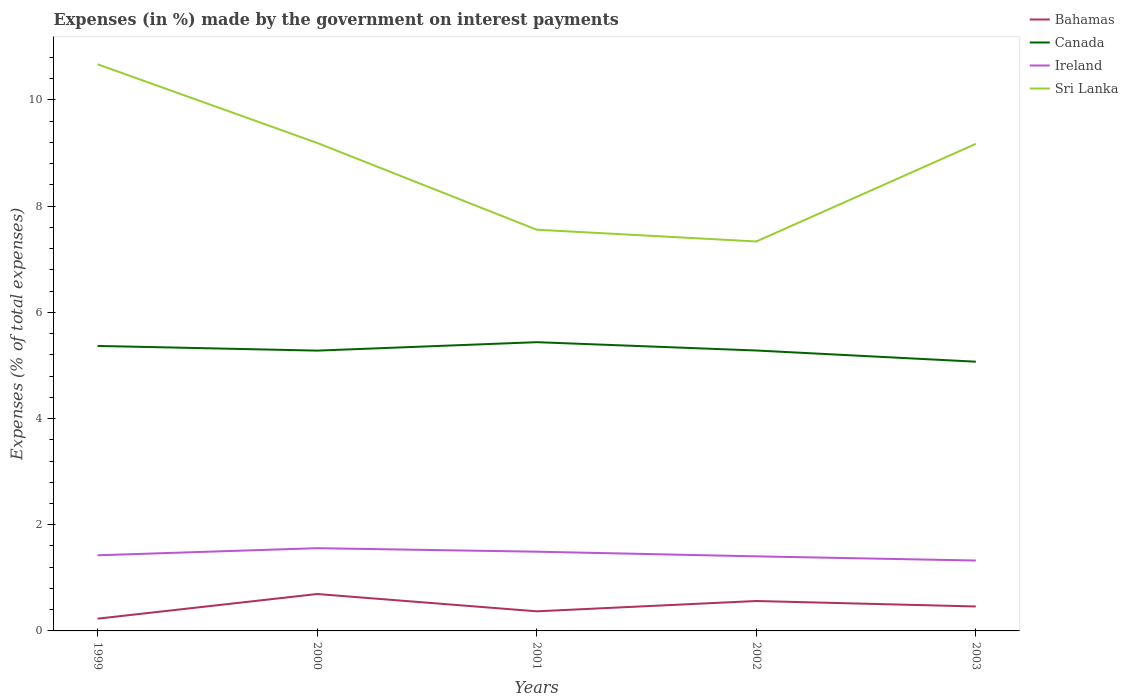How many different coloured lines are there?
Provide a succinct answer. 4. Does the line corresponding to Ireland intersect with the line corresponding to Sri Lanka?
Your answer should be very brief. No. Is the number of lines equal to the number of legend labels?
Your response must be concise. Yes. Across all years, what is the maximum percentage of expenses made by the government on interest payments in Sri Lanka?
Your response must be concise. 7.33. In which year was the percentage of expenses made by the government on interest payments in Ireland maximum?
Give a very brief answer. 2003. What is the total percentage of expenses made by the government on interest payments in Canada in the graph?
Your response must be concise. -0.16. What is the difference between the highest and the second highest percentage of expenses made by the government on interest payments in Ireland?
Offer a terse response. 0.23. What is the difference between the highest and the lowest percentage of expenses made by the government on interest payments in Bahamas?
Ensure brevity in your answer.  2. Is the percentage of expenses made by the government on interest payments in Ireland strictly greater than the percentage of expenses made by the government on interest payments in Sri Lanka over the years?
Give a very brief answer. Yes. What is the difference between two consecutive major ticks on the Y-axis?
Ensure brevity in your answer.  2. Does the graph contain any zero values?
Provide a short and direct response. No. How many legend labels are there?
Provide a succinct answer. 4. How are the legend labels stacked?
Offer a terse response. Vertical. What is the title of the graph?
Your answer should be compact. Expenses (in %) made by the government on interest payments. Does "Slovak Republic" appear as one of the legend labels in the graph?
Your answer should be compact. No. What is the label or title of the Y-axis?
Offer a very short reply. Expenses (% of total expenses). What is the Expenses (% of total expenses) in Bahamas in 1999?
Ensure brevity in your answer.  0.23. What is the Expenses (% of total expenses) of Canada in 1999?
Give a very brief answer. 5.37. What is the Expenses (% of total expenses) of Ireland in 1999?
Provide a succinct answer. 1.42. What is the Expenses (% of total expenses) of Sri Lanka in 1999?
Give a very brief answer. 10.67. What is the Expenses (% of total expenses) of Bahamas in 2000?
Your answer should be very brief. 0.7. What is the Expenses (% of total expenses) of Canada in 2000?
Your answer should be very brief. 5.28. What is the Expenses (% of total expenses) of Ireland in 2000?
Provide a short and direct response. 1.56. What is the Expenses (% of total expenses) of Sri Lanka in 2000?
Your answer should be compact. 9.19. What is the Expenses (% of total expenses) of Bahamas in 2001?
Ensure brevity in your answer.  0.37. What is the Expenses (% of total expenses) of Canada in 2001?
Your answer should be very brief. 5.44. What is the Expenses (% of total expenses) in Ireland in 2001?
Keep it short and to the point. 1.49. What is the Expenses (% of total expenses) in Sri Lanka in 2001?
Your answer should be very brief. 7.56. What is the Expenses (% of total expenses) of Bahamas in 2002?
Provide a short and direct response. 0.56. What is the Expenses (% of total expenses) in Canada in 2002?
Ensure brevity in your answer.  5.28. What is the Expenses (% of total expenses) of Ireland in 2002?
Provide a succinct answer. 1.4. What is the Expenses (% of total expenses) of Sri Lanka in 2002?
Provide a short and direct response. 7.33. What is the Expenses (% of total expenses) of Bahamas in 2003?
Provide a short and direct response. 0.46. What is the Expenses (% of total expenses) in Canada in 2003?
Keep it short and to the point. 5.07. What is the Expenses (% of total expenses) of Ireland in 2003?
Keep it short and to the point. 1.33. What is the Expenses (% of total expenses) of Sri Lanka in 2003?
Provide a short and direct response. 9.17. Across all years, what is the maximum Expenses (% of total expenses) in Bahamas?
Give a very brief answer. 0.7. Across all years, what is the maximum Expenses (% of total expenses) of Canada?
Provide a short and direct response. 5.44. Across all years, what is the maximum Expenses (% of total expenses) of Ireland?
Your answer should be compact. 1.56. Across all years, what is the maximum Expenses (% of total expenses) in Sri Lanka?
Make the answer very short. 10.67. Across all years, what is the minimum Expenses (% of total expenses) of Bahamas?
Ensure brevity in your answer.  0.23. Across all years, what is the minimum Expenses (% of total expenses) of Canada?
Offer a terse response. 5.07. Across all years, what is the minimum Expenses (% of total expenses) in Ireland?
Provide a succinct answer. 1.33. Across all years, what is the minimum Expenses (% of total expenses) of Sri Lanka?
Provide a succinct answer. 7.33. What is the total Expenses (% of total expenses) of Bahamas in the graph?
Provide a succinct answer. 2.32. What is the total Expenses (% of total expenses) in Canada in the graph?
Your answer should be compact. 26.44. What is the total Expenses (% of total expenses) of Ireland in the graph?
Give a very brief answer. 7.21. What is the total Expenses (% of total expenses) in Sri Lanka in the graph?
Give a very brief answer. 43.92. What is the difference between the Expenses (% of total expenses) in Bahamas in 1999 and that in 2000?
Your answer should be very brief. -0.46. What is the difference between the Expenses (% of total expenses) of Canada in 1999 and that in 2000?
Ensure brevity in your answer.  0.09. What is the difference between the Expenses (% of total expenses) in Ireland in 1999 and that in 2000?
Provide a short and direct response. -0.13. What is the difference between the Expenses (% of total expenses) of Sri Lanka in 1999 and that in 2000?
Offer a terse response. 1.48. What is the difference between the Expenses (% of total expenses) of Bahamas in 1999 and that in 2001?
Give a very brief answer. -0.14. What is the difference between the Expenses (% of total expenses) of Canada in 1999 and that in 2001?
Keep it short and to the point. -0.07. What is the difference between the Expenses (% of total expenses) of Ireland in 1999 and that in 2001?
Ensure brevity in your answer.  -0.07. What is the difference between the Expenses (% of total expenses) in Sri Lanka in 1999 and that in 2001?
Make the answer very short. 3.12. What is the difference between the Expenses (% of total expenses) of Bahamas in 1999 and that in 2002?
Your response must be concise. -0.33. What is the difference between the Expenses (% of total expenses) of Canada in 1999 and that in 2002?
Keep it short and to the point. 0.09. What is the difference between the Expenses (% of total expenses) in Sri Lanka in 1999 and that in 2002?
Your answer should be very brief. 3.34. What is the difference between the Expenses (% of total expenses) of Bahamas in 1999 and that in 2003?
Make the answer very short. -0.23. What is the difference between the Expenses (% of total expenses) of Canada in 1999 and that in 2003?
Provide a short and direct response. 0.3. What is the difference between the Expenses (% of total expenses) in Ireland in 1999 and that in 2003?
Provide a short and direct response. 0.1. What is the difference between the Expenses (% of total expenses) in Sri Lanka in 1999 and that in 2003?
Provide a short and direct response. 1.5. What is the difference between the Expenses (% of total expenses) in Bahamas in 2000 and that in 2001?
Your answer should be compact. 0.33. What is the difference between the Expenses (% of total expenses) of Canada in 2000 and that in 2001?
Provide a succinct answer. -0.16. What is the difference between the Expenses (% of total expenses) in Ireland in 2000 and that in 2001?
Offer a terse response. 0.07. What is the difference between the Expenses (% of total expenses) in Sri Lanka in 2000 and that in 2001?
Your answer should be very brief. 1.63. What is the difference between the Expenses (% of total expenses) in Bahamas in 2000 and that in 2002?
Ensure brevity in your answer.  0.13. What is the difference between the Expenses (% of total expenses) of Canada in 2000 and that in 2002?
Ensure brevity in your answer.  -0. What is the difference between the Expenses (% of total expenses) of Ireland in 2000 and that in 2002?
Give a very brief answer. 0.15. What is the difference between the Expenses (% of total expenses) in Sri Lanka in 2000 and that in 2002?
Your response must be concise. 1.86. What is the difference between the Expenses (% of total expenses) of Bahamas in 2000 and that in 2003?
Provide a succinct answer. 0.23. What is the difference between the Expenses (% of total expenses) in Canada in 2000 and that in 2003?
Make the answer very short. 0.21. What is the difference between the Expenses (% of total expenses) of Ireland in 2000 and that in 2003?
Offer a very short reply. 0.23. What is the difference between the Expenses (% of total expenses) in Sri Lanka in 2000 and that in 2003?
Keep it short and to the point. 0.02. What is the difference between the Expenses (% of total expenses) in Bahamas in 2001 and that in 2002?
Give a very brief answer. -0.19. What is the difference between the Expenses (% of total expenses) in Canada in 2001 and that in 2002?
Ensure brevity in your answer.  0.16. What is the difference between the Expenses (% of total expenses) in Ireland in 2001 and that in 2002?
Provide a short and direct response. 0.09. What is the difference between the Expenses (% of total expenses) in Sri Lanka in 2001 and that in 2002?
Provide a short and direct response. 0.22. What is the difference between the Expenses (% of total expenses) of Bahamas in 2001 and that in 2003?
Your answer should be compact. -0.09. What is the difference between the Expenses (% of total expenses) of Canada in 2001 and that in 2003?
Ensure brevity in your answer.  0.37. What is the difference between the Expenses (% of total expenses) in Ireland in 2001 and that in 2003?
Offer a terse response. 0.17. What is the difference between the Expenses (% of total expenses) in Sri Lanka in 2001 and that in 2003?
Provide a succinct answer. -1.62. What is the difference between the Expenses (% of total expenses) in Bahamas in 2002 and that in 2003?
Your answer should be compact. 0.1. What is the difference between the Expenses (% of total expenses) of Canada in 2002 and that in 2003?
Offer a very short reply. 0.21. What is the difference between the Expenses (% of total expenses) in Ireland in 2002 and that in 2003?
Your answer should be compact. 0.08. What is the difference between the Expenses (% of total expenses) in Sri Lanka in 2002 and that in 2003?
Your answer should be compact. -1.84. What is the difference between the Expenses (% of total expenses) of Bahamas in 1999 and the Expenses (% of total expenses) of Canada in 2000?
Your answer should be compact. -5.05. What is the difference between the Expenses (% of total expenses) of Bahamas in 1999 and the Expenses (% of total expenses) of Ireland in 2000?
Your response must be concise. -1.33. What is the difference between the Expenses (% of total expenses) in Bahamas in 1999 and the Expenses (% of total expenses) in Sri Lanka in 2000?
Offer a very short reply. -8.96. What is the difference between the Expenses (% of total expenses) of Canada in 1999 and the Expenses (% of total expenses) of Ireland in 2000?
Make the answer very short. 3.81. What is the difference between the Expenses (% of total expenses) of Canada in 1999 and the Expenses (% of total expenses) of Sri Lanka in 2000?
Provide a short and direct response. -3.82. What is the difference between the Expenses (% of total expenses) in Ireland in 1999 and the Expenses (% of total expenses) in Sri Lanka in 2000?
Your answer should be very brief. -7.77. What is the difference between the Expenses (% of total expenses) of Bahamas in 1999 and the Expenses (% of total expenses) of Canada in 2001?
Your answer should be compact. -5.21. What is the difference between the Expenses (% of total expenses) in Bahamas in 1999 and the Expenses (% of total expenses) in Ireland in 2001?
Your response must be concise. -1.26. What is the difference between the Expenses (% of total expenses) in Bahamas in 1999 and the Expenses (% of total expenses) in Sri Lanka in 2001?
Provide a succinct answer. -7.33. What is the difference between the Expenses (% of total expenses) in Canada in 1999 and the Expenses (% of total expenses) in Ireland in 2001?
Ensure brevity in your answer.  3.88. What is the difference between the Expenses (% of total expenses) of Canada in 1999 and the Expenses (% of total expenses) of Sri Lanka in 2001?
Offer a terse response. -2.19. What is the difference between the Expenses (% of total expenses) of Ireland in 1999 and the Expenses (% of total expenses) of Sri Lanka in 2001?
Make the answer very short. -6.13. What is the difference between the Expenses (% of total expenses) in Bahamas in 1999 and the Expenses (% of total expenses) in Canada in 2002?
Provide a succinct answer. -5.05. What is the difference between the Expenses (% of total expenses) of Bahamas in 1999 and the Expenses (% of total expenses) of Ireland in 2002?
Offer a terse response. -1.17. What is the difference between the Expenses (% of total expenses) of Bahamas in 1999 and the Expenses (% of total expenses) of Sri Lanka in 2002?
Offer a terse response. -7.1. What is the difference between the Expenses (% of total expenses) in Canada in 1999 and the Expenses (% of total expenses) in Ireland in 2002?
Keep it short and to the point. 3.96. What is the difference between the Expenses (% of total expenses) in Canada in 1999 and the Expenses (% of total expenses) in Sri Lanka in 2002?
Your answer should be very brief. -1.97. What is the difference between the Expenses (% of total expenses) of Ireland in 1999 and the Expenses (% of total expenses) of Sri Lanka in 2002?
Offer a terse response. -5.91. What is the difference between the Expenses (% of total expenses) of Bahamas in 1999 and the Expenses (% of total expenses) of Canada in 2003?
Offer a terse response. -4.84. What is the difference between the Expenses (% of total expenses) in Bahamas in 1999 and the Expenses (% of total expenses) in Ireland in 2003?
Ensure brevity in your answer.  -1.09. What is the difference between the Expenses (% of total expenses) in Bahamas in 1999 and the Expenses (% of total expenses) in Sri Lanka in 2003?
Give a very brief answer. -8.94. What is the difference between the Expenses (% of total expenses) in Canada in 1999 and the Expenses (% of total expenses) in Ireland in 2003?
Provide a short and direct response. 4.04. What is the difference between the Expenses (% of total expenses) of Canada in 1999 and the Expenses (% of total expenses) of Sri Lanka in 2003?
Your answer should be very brief. -3.81. What is the difference between the Expenses (% of total expenses) in Ireland in 1999 and the Expenses (% of total expenses) in Sri Lanka in 2003?
Make the answer very short. -7.75. What is the difference between the Expenses (% of total expenses) in Bahamas in 2000 and the Expenses (% of total expenses) in Canada in 2001?
Your answer should be very brief. -4.74. What is the difference between the Expenses (% of total expenses) of Bahamas in 2000 and the Expenses (% of total expenses) of Ireland in 2001?
Your answer should be very brief. -0.8. What is the difference between the Expenses (% of total expenses) of Bahamas in 2000 and the Expenses (% of total expenses) of Sri Lanka in 2001?
Ensure brevity in your answer.  -6.86. What is the difference between the Expenses (% of total expenses) of Canada in 2000 and the Expenses (% of total expenses) of Ireland in 2001?
Make the answer very short. 3.79. What is the difference between the Expenses (% of total expenses) in Canada in 2000 and the Expenses (% of total expenses) in Sri Lanka in 2001?
Give a very brief answer. -2.28. What is the difference between the Expenses (% of total expenses) of Ireland in 2000 and the Expenses (% of total expenses) of Sri Lanka in 2001?
Your response must be concise. -6. What is the difference between the Expenses (% of total expenses) of Bahamas in 2000 and the Expenses (% of total expenses) of Canada in 2002?
Keep it short and to the point. -4.59. What is the difference between the Expenses (% of total expenses) of Bahamas in 2000 and the Expenses (% of total expenses) of Ireland in 2002?
Your answer should be very brief. -0.71. What is the difference between the Expenses (% of total expenses) in Bahamas in 2000 and the Expenses (% of total expenses) in Sri Lanka in 2002?
Provide a succinct answer. -6.64. What is the difference between the Expenses (% of total expenses) in Canada in 2000 and the Expenses (% of total expenses) in Ireland in 2002?
Give a very brief answer. 3.87. What is the difference between the Expenses (% of total expenses) in Canada in 2000 and the Expenses (% of total expenses) in Sri Lanka in 2002?
Offer a very short reply. -2.06. What is the difference between the Expenses (% of total expenses) in Ireland in 2000 and the Expenses (% of total expenses) in Sri Lanka in 2002?
Ensure brevity in your answer.  -5.78. What is the difference between the Expenses (% of total expenses) of Bahamas in 2000 and the Expenses (% of total expenses) of Canada in 2003?
Your response must be concise. -4.38. What is the difference between the Expenses (% of total expenses) of Bahamas in 2000 and the Expenses (% of total expenses) of Ireland in 2003?
Make the answer very short. -0.63. What is the difference between the Expenses (% of total expenses) of Bahamas in 2000 and the Expenses (% of total expenses) of Sri Lanka in 2003?
Give a very brief answer. -8.48. What is the difference between the Expenses (% of total expenses) of Canada in 2000 and the Expenses (% of total expenses) of Ireland in 2003?
Provide a short and direct response. 3.95. What is the difference between the Expenses (% of total expenses) of Canada in 2000 and the Expenses (% of total expenses) of Sri Lanka in 2003?
Ensure brevity in your answer.  -3.89. What is the difference between the Expenses (% of total expenses) in Ireland in 2000 and the Expenses (% of total expenses) in Sri Lanka in 2003?
Offer a terse response. -7.61. What is the difference between the Expenses (% of total expenses) in Bahamas in 2001 and the Expenses (% of total expenses) in Canada in 2002?
Provide a short and direct response. -4.91. What is the difference between the Expenses (% of total expenses) in Bahamas in 2001 and the Expenses (% of total expenses) in Ireland in 2002?
Make the answer very short. -1.04. What is the difference between the Expenses (% of total expenses) in Bahamas in 2001 and the Expenses (% of total expenses) in Sri Lanka in 2002?
Your response must be concise. -6.97. What is the difference between the Expenses (% of total expenses) of Canada in 2001 and the Expenses (% of total expenses) of Ireland in 2002?
Your answer should be compact. 4.03. What is the difference between the Expenses (% of total expenses) in Canada in 2001 and the Expenses (% of total expenses) in Sri Lanka in 2002?
Your response must be concise. -1.9. What is the difference between the Expenses (% of total expenses) of Ireland in 2001 and the Expenses (% of total expenses) of Sri Lanka in 2002?
Offer a very short reply. -5.84. What is the difference between the Expenses (% of total expenses) in Bahamas in 2001 and the Expenses (% of total expenses) in Canada in 2003?
Provide a short and direct response. -4.7. What is the difference between the Expenses (% of total expenses) in Bahamas in 2001 and the Expenses (% of total expenses) in Ireland in 2003?
Offer a very short reply. -0.96. What is the difference between the Expenses (% of total expenses) in Bahamas in 2001 and the Expenses (% of total expenses) in Sri Lanka in 2003?
Make the answer very short. -8.8. What is the difference between the Expenses (% of total expenses) of Canada in 2001 and the Expenses (% of total expenses) of Ireland in 2003?
Your answer should be very brief. 4.11. What is the difference between the Expenses (% of total expenses) of Canada in 2001 and the Expenses (% of total expenses) of Sri Lanka in 2003?
Keep it short and to the point. -3.73. What is the difference between the Expenses (% of total expenses) of Ireland in 2001 and the Expenses (% of total expenses) of Sri Lanka in 2003?
Give a very brief answer. -7.68. What is the difference between the Expenses (% of total expenses) of Bahamas in 2002 and the Expenses (% of total expenses) of Canada in 2003?
Give a very brief answer. -4.51. What is the difference between the Expenses (% of total expenses) in Bahamas in 2002 and the Expenses (% of total expenses) in Ireland in 2003?
Your response must be concise. -0.76. What is the difference between the Expenses (% of total expenses) of Bahamas in 2002 and the Expenses (% of total expenses) of Sri Lanka in 2003?
Your response must be concise. -8.61. What is the difference between the Expenses (% of total expenses) of Canada in 2002 and the Expenses (% of total expenses) of Ireland in 2003?
Provide a short and direct response. 3.96. What is the difference between the Expenses (% of total expenses) in Canada in 2002 and the Expenses (% of total expenses) in Sri Lanka in 2003?
Give a very brief answer. -3.89. What is the difference between the Expenses (% of total expenses) in Ireland in 2002 and the Expenses (% of total expenses) in Sri Lanka in 2003?
Ensure brevity in your answer.  -7.77. What is the average Expenses (% of total expenses) in Bahamas per year?
Give a very brief answer. 0.46. What is the average Expenses (% of total expenses) in Canada per year?
Make the answer very short. 5.29. What is the average Expenses (% of total expenses) in Ireland per year?
Your response must be concise. 1.44. What is the average Expenses (% of total expenses) in Sri Lanka per year?
Provide a succinct answer. 8.78. In the year 1999, what is the difference between the Expenses (% of total expenses) in Bahamas and Expenses (% of total expenses) in Canada?
Offer a terse response. -5.14. In the year 1999, what is the difference between the Expenses (% of total expenses) in Bahamas and Expenses (% of total expenses) in Ireland?
Keep it short and to the point. -1.19. In the year 1999, what is the difference between the Expenses (% of total expenses) in Bahamas and Expenses (% of total expenses) in Sri Lanka?
Offer a terse response. -10.44. In the year 1999, what is the difference between the Expenses (% of total expenses) of Canada and Expenses (% of total expenses) of Ireland?
Your answer should be very brief. 3.94. In the year 1999, what is the difference between the Expenses (% of total expenses) of Canada and Expenses (% of total expenses) of Sri Lanka?
Make the answer very short. -5.3. In the year 1999, what is the difference between the Expenses (% of total expenses) of Ireland and Expenses (% of total expenses) of Sri Lanka?
Keep it short and to the point. -9.25. In the year 2000, what is the difference between the Expenses (% of total expenses) in Bahamas and Expenses (% of total expenses) in Canada?
Ensure brevity in your answer.  -4.58. In the year 2000, what is the difference between the Expenses (% of total expenses) in Bahamas and Expenses (% of total expenses) in Ireland?
Provide a short and direct response. -0.86. In the year 2000, what is the difference between the Expenses (% of total expenses) of Bahamas and Expenses (% of total expenses) of Sri Lanka?
Offer a very short reply. -8.5. In the year 2000, what is the difference between the Expenses (% of total expenses) of Canada and Expenses (% of total expenses) of Ireland?
Your response must be concise. 3.72. In the year 2000, what is the difference between the Expenses (% of total expenses) of Canada and Expenses (% of total expenses) of Sri Lanka?
Your answer should be compact. -3.91. In the year 2000, what is the difference between the Expenses (% of total expenses) of Ireland and Expenses (% of total expenses) of Sri Lanka?
Keep it short and to the point. -7.63. In the year 2001, what is the difference between the Expenses (% of total expenses) of Bahamas and Expenses (% of total expenses) of Canada?
Provide a succinct answer. -5.07. In the year 2001, what is the difference between the Expenses (% of total expenses) in Bahamas and Expenses (% of total expenses) in Ireland?
Provide a succinct answer. -1.12. In the year 2001, what is the difference between the Expenses (% of total expenses) in Bahamas and Expenses (% of total expenses) in Sri Lanka?
Give a very brief answer. -7.19. In the year 2001, what is the difference between the Expenses (% of total expenses) in Canada and Expenses (% of total expenses) in Ireland?
Provide a succinct answer. 3.95. In the year 2001, what is the difference between the Expenses (% of total expenses) of Canada and Expenses (% of total expenses) of Sri Lanka?
Keep it short and to the point. -2.12. In the year 2001, what is the difference between the Expenses (% of total expenses) of Ireland and Expenses (% of total expenses) of Sri Lanka?
Provide a short and direct response. -6.06. In the year 2002, what is the difference between the Expenses (% of total expenses) in Bahamas and Expenses (% of total expenses) in Canada?
Keep it short and to the point. -4.72. In the year 2002, what is the difference between the Expenses (% of total expenses) of Bahamas and Expenses (% of total expenses) of Ireland?
Give a very brief answer. -0.84. In the year 2002, what is the difference between the Expenses (% of total expenses) of Bahamas and Expenses (% of total expenses) of Sri Lanka?
Offer a terse response. -6.77. In the year 2002, what is the difference between the Expenses (% of total expenses) in Canada and Expenses (% of total expenses) in Ireland?
Provide a succinct answer. 3.88. In the year 2002, what is the difference between the Expenses (% of total expenses) of Canada and Expenses (% of total expenses) of Sri Lanka?
Your response must be concise. -2.05. In the year 2002, what is the difference between the Expenses (% of total expenses) in Ireland and Expenses (% of total expenses) in Sri Lanka?
Provide a succinct answer. -5.93. In the year 2003, what is the difference between the Expenses (% of total expenses) of Bahamas and Expenses (% of total expenses) of Canada?
Provide a succinct answer. -4.61. In the year 2003, what is the difference between the Expenses (% of total expenses) of Bahamas and Expenses (% of total expenses) of Ireland?
Keep it short and to the point. -0.87. In the year 2003, what is the difference between the Expenses (% of total expenses) in Bahamas and Expenses (% of total expenses) in Sri Lanka?
Provide a short and direct response. -8.71. In the year 2003, what is the difference between the Expenses (% of total expenses) of Canada and Expenses (% of total expenses) of Ireland?
Your response must be concise. 3.74. In the year 2003, what is the difference between the Expenses (% of total expenses) of Canada and Expenses (% of total expenses) of Sri Lanka?
Keep it short and to the point. -4.1. In the year 2003, what is the difference between the Expenses (% of total expenses) of Ireland and Expenses (% of total expenses) of Sri Lanka?
Your answer should be compact. -7.85. What is the ratio of the Expenses (% of total expenses) of Bahamas in 1999 to that in 2000?
Offer a very short reply. 0.33. What is the ratio of the Expenses (% of total expenses) of Canada in 1999 to that in 2000?
Your response must be concise. 1.02. What is the ratio of the Expenses (% of total expenses) of Ireland in 1999 to that in 2000?
Make the answer very short. 0.91. What is the ratio of the Expenses (% of total expenses) in Sri Lanka in 1999 to that in 2000?
Make the answer very short. 1.16. What is the ratio of the Expenses (% of total expenses) of Canada in 1999 to that in 2001?
Ensure brevity in your answer.  0.99. What is the ratio of the Expenses (% of total expenses) in Ireland in 1999 to that in 2001?
Offer a terse response. 0.95. What is the ratio of the Expenses (% of total expenses) in Sri Lanka in 1999 to that in 2001?
Your response must be concise. 1.41. What is the ratio of the Expenses (% of total expenses) in Bahamas in 1999 to that in 2002?
Provide a short and direct response. 0.41. What is the ratio of the Expenses (% of total expenses) of Canada in 1999 to that in 2002?
Provide a succinct answer. 1.02. What is the ratio of the Expenses (% of total expenses) of Ireland in 1999 to that in 2002?
Keep it short and to the point. 1.01. What is the ratio of the Expenses (% of total expenses) of Sri Lanka in 1999 to that in 2002?
Provide a succinct answer. 1.46. What is the ratio of the Expenses (% of total expenses) of Bahamas in 1999 to that in 2003?
Provide a short and direct response. 0.5. What is the ratio of the Expenses (% of total expenses) of Canada in 1999 to that in 2003?
Your answer should be compact. 1.06. What is the ratio of the Expenses (% of total expenses) of Ireland in 1999 to that in 2003?
Make the answer very short. 1.07. What is the ratio of the Expenses (% of total expenses) of Sri Lanka in 1999 to that in 2003?
Your answer should be compact. 1.16. What is the ratio of the Expenses (% of total expenses) in Bahamas in 2000 to that in 2001?
Offer a terse response. 1.88. What is the ratio of the Expenses (% of total expenses) in Canada in 2000 to that in 2001?
Give a very brief answer. 0.97. What is the ratio of the Expenses (% of total expenses) in Ireland in 2000 to that in 2001?
Offer a very short reply. 1.04. What is the ratio of the Expenses (% of total expenses) of Sri Lanka in 2000 to that in 2001?
Give a very brief answer. 1.22. What is the ratio of the Expenses (% of total expenses) of Bahamas in 2000 to that in 2002?
Offer a terse response. 1.23. What is the ratio of the Expenses (% of total expenses) in Canada in 2000 to that in 2002?
Make the answer very short. 1. What is the ratio of the Expenses (% of total expenses) in Ireland in 2000 to that in 2002?
Your answer should be very brief. 1.11. What is the ratio of the Expenses (% of total expenses) of Sri Lanka in 2000 to that in 2002?
Your response must be concise. 1.25. What is the ratio of the Expenses (% of total expenses) in Bahamas in 2000 to that in 2003?
Keep it short and to the point. 1.51. What is the ratio of the Expenses (% of total expenses) of Canada in 2000 to that in 2003?
Your response must be concise. 1.04. What is the ratio of the Expenses (% of total expenses) in Ireland in 2000 to that in 2003?
Your response must be concise. 1.18. What is the ratio of the Expenses (% of total expenses) of Sri Lanka in 2000 to that in 2003?
Your answer should be compact. 1. What is the ratio of the Expenses (% of total expenses) in Bahamas in 2001 to that in 2002?
Keep it short and to the point. 0.65. What is the ratio of the Expenses (% of total expenses) in Canada in 2001 to that in 2002?
Make the answer very short. 1.03. What is the ratio of the Expenses (% of total expenses) in Ireland in 2001 to that in 2002?
Keep it short and to the point. 1.06. What is the ratio of the Expenses (% of total expenses) in Sri Lanka in 2001 to that in 2002?
Keep it short and to the point. 1.03. What is the ratio of the Expenses (% of total expenses) of Bahamas in 2001 to that in 2003?
Ensure brevity in your answer.  0.8. What is the ratio of the Expenses (% of total expenses) in Canada in 2001 to that in 2003?
Provide a short and direct response. 1.07. What is the ratio of the Expenses (% of total expenses) in Ireland in 2001 to that in 2003?
Provide a succinct answer. 1.13. What is the ratio of the Expenses (% of total expenses) in Sri Lanka in 2001 to that in 2003?
Your answer should be very brief. 0.82. What is the ratio of the Expenses (% of total expenses) of Bahamas in 2002 to that in 2003?
Your response must be concise. 1.22. What is the ratio of the Expenses (% of total expenses) of Canada in 2002 to that in 2003?
Provide a short and direct response. 1.04. What is the ratio of the Expenses (% of total expenses) in Ireland in 2002 to that in 2003?
Your answer should be very brief. 1.06. What is the ratio of the Expenses (% of total expenses) of Sri Lanka in 2002 to that in 2003?
Provide a succinct answer. 0.8. What is the difference between the highest and the second highest Expenses (% of total expenses) of Bahamas?
Your answer should be very brief. 0.13. What is the difference between the highest and the second highest Expenses (% of total expenses) of Canada?
Provide a succinct answer. 0.07. What is the difference between the highest and the second highest Expenses (% of total expenses) in Ireland?
Offer a terse response. 0.07. What is the difference between the highest and the second highest Expenses (% of total expenses) of Sri Lanka?
Provide a short and direct response. 1.48. What is the difference between the highest and the lowest Expenses (% of total expenses) in Bahamas?
Your response must be concise. 0.46. What is the difference between the highest and the lowest Expenses (% of total expenses) in Canada?
Offer a terse response. 0.37. What is the difference between the highest and the lowest Expenses (% of total expenses) of Ireland?
Give a very brief answer. 0.23. What is the difference between the highest and the lowest Expenses (% of total expenses) in Sri Lanka?
Provide a succinct answer. 3.34. 